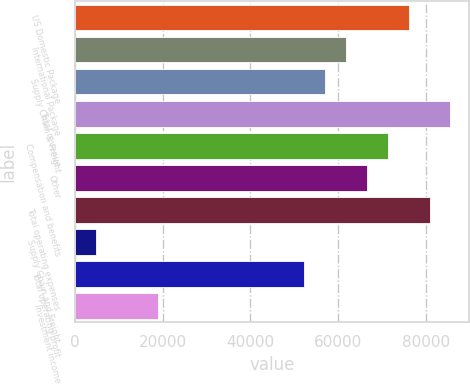Convert chart. <chart><loc_0><loc_0><loc_500><loc_500><bar_chart><fcel>US Domestic Package<fcel>International Package<fcel>Supply Chain & Freight<fcel>Total revenue<fcel>Compensation and benefits<fcel>Other<fcel>Total operating expenses<fcel>Supply Chain and Freight<fcel>Total operating profit<fcel>Investment income<nl><fcel>76074.3<fcel>61810.7<fcel>57056.1<fcel>85583.4<fcel>71319.8<fcel>66565.2<fcel>80828.9<fcel>4756.07<fcel>52301.6<fcel>19019.7<nl></chart> 